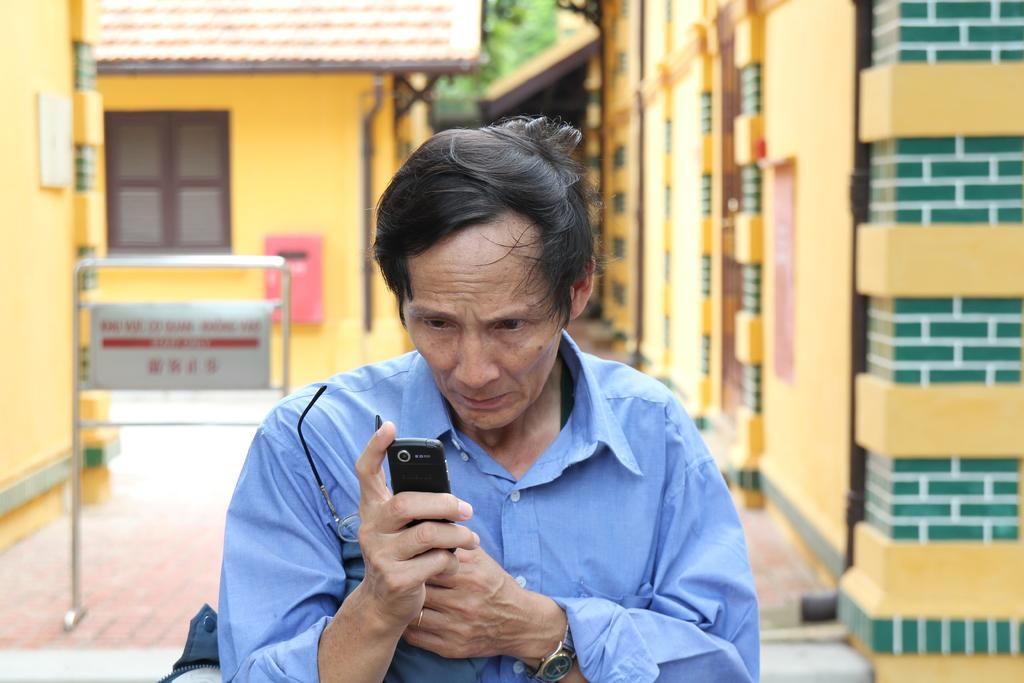What can be seen in the image? There is a person in the image. What is the person wearing? The person is wearing a blue shirt. What is the person holding in their hands? The person is holding spectacles in one hand and a mobile in the other hand. What can be seen in the background of the image? There are yellow buildings in the background of the image. What type of coal is being transported along the route in the image? There is no coal or route present in the image; it features a person holding spectacles and a mobile, with yellow buildings in the background. 